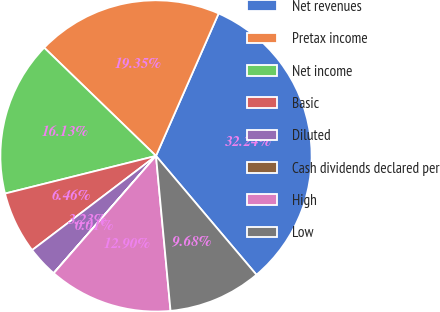<chart> <loc_0><loc_0><loc_500><loc_500><pie_chart><fcel>Net revenues<fcel>Pretax income<fcel>Net income<fcel>Basic<fcel>Diluted<fcel>Cash dividends declared per<fcel>High<fcel>Low<nl><fcel>32.24%<fcel>19.35%<fcel>16.13%<fcel>6.46%<fcel>3.23%<fcel>0.01%<fcel>12.9%<fcel>9.68%<nl></chart> 